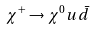Convert formula to latex. <formula><loc_0><loc_0><loc_500><loc_500>\chi ^ { + } \rightarrow \chi ^ { 0 } u \bar { d }</formula> 